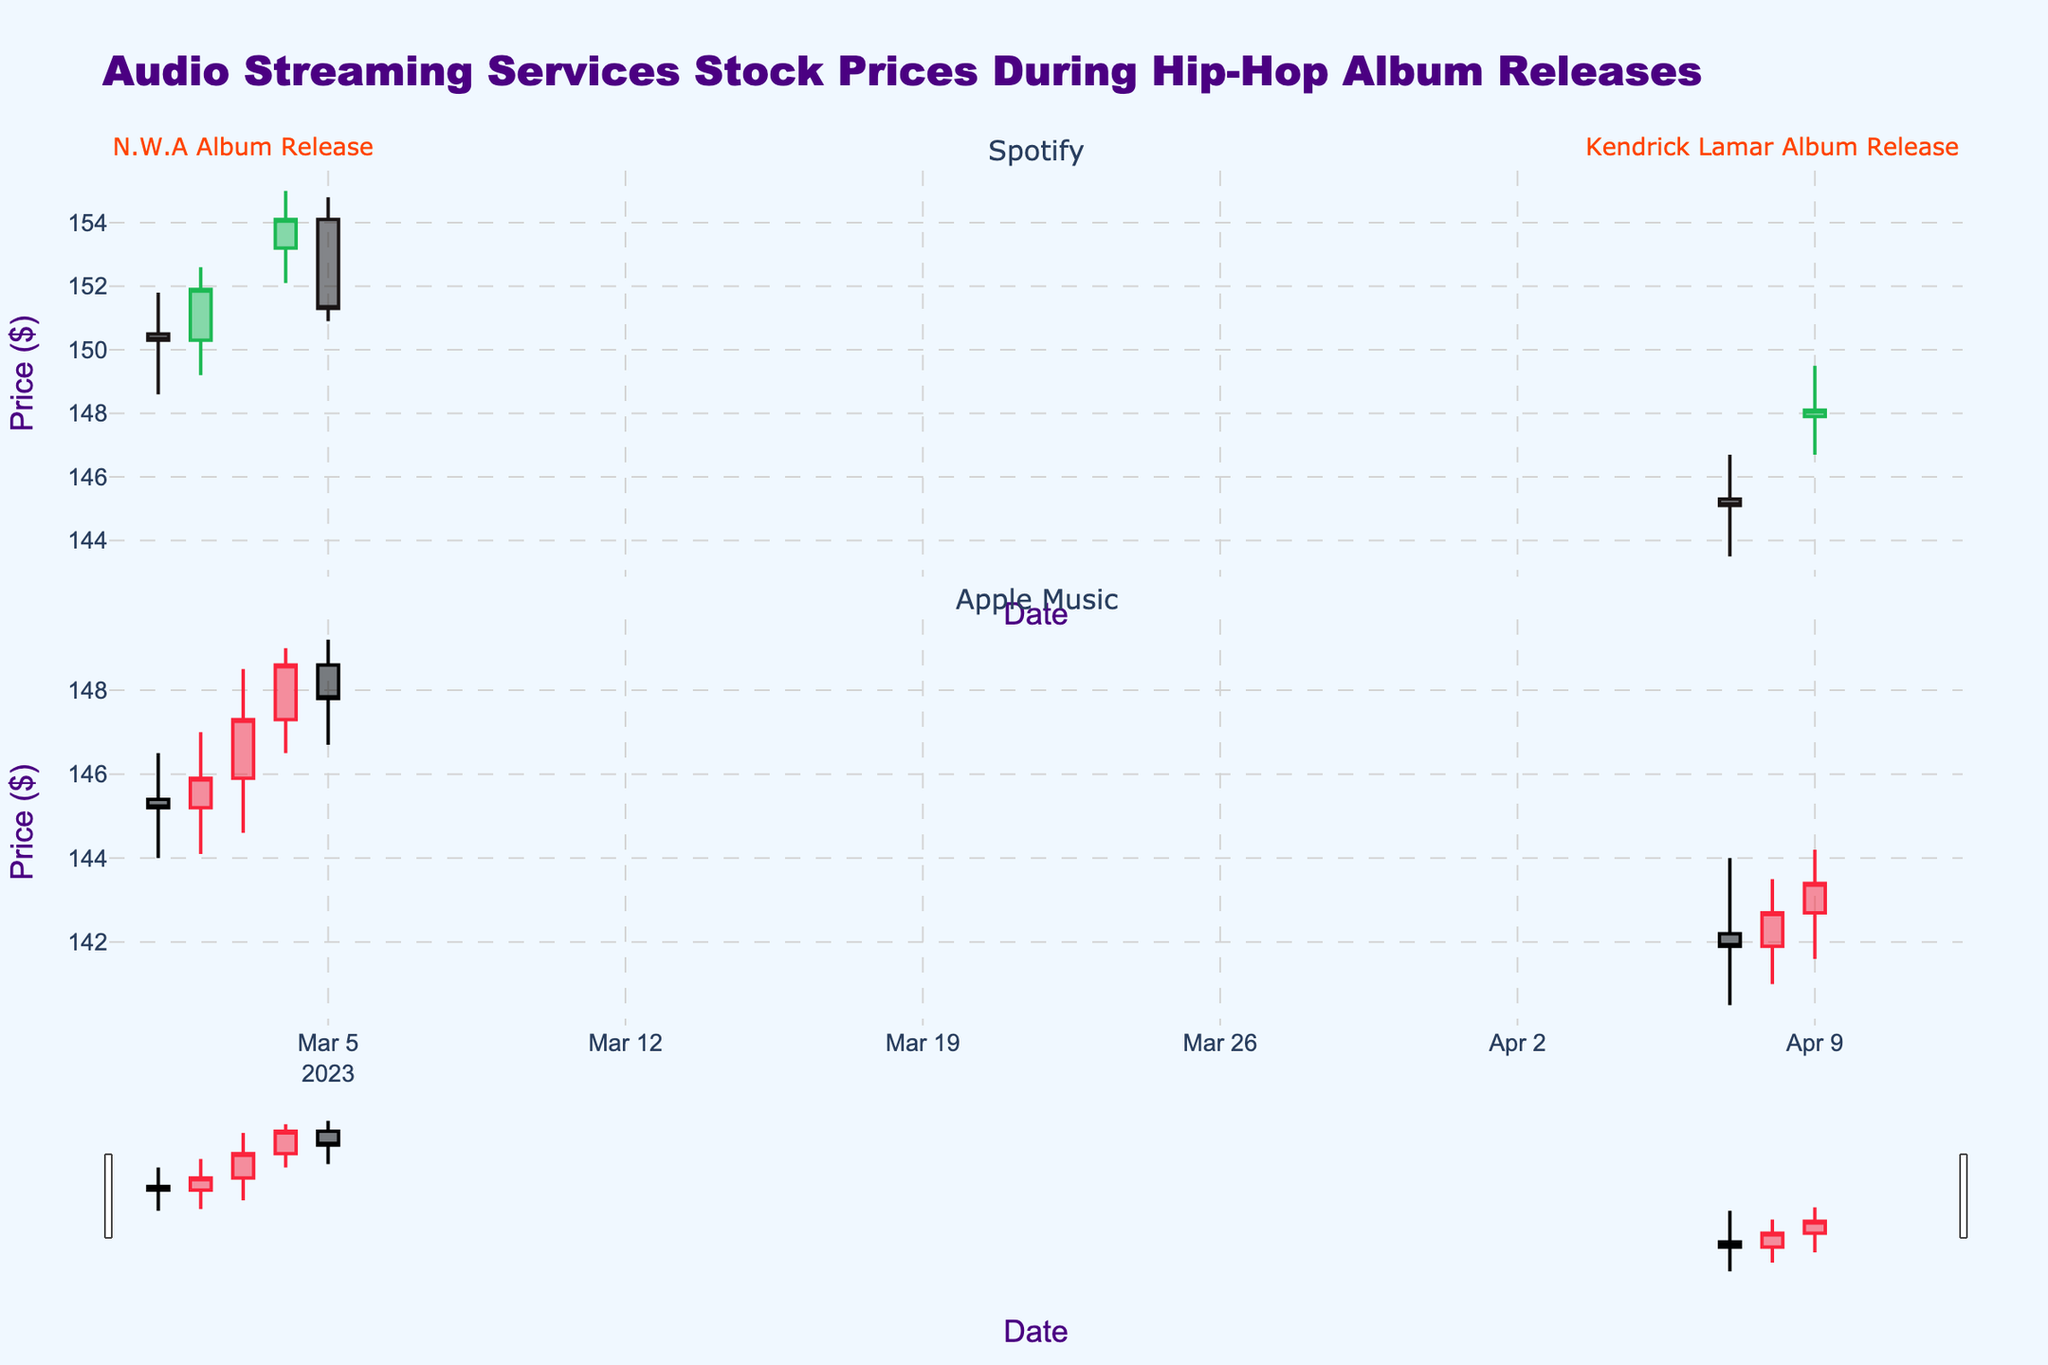What does the title of the plot indicate? The title of the plot, "Audio Streaming Services Stock Prices During Hip-Hop Album Releases," provides an overview that the candlestick chart visualizes the stock price movements of audio streaming services (Spotify and Apple Music) during major hip-hop album releases (N.W.A and Kendrick Lamar).
Answer: It indicates stock price movements during hip-hop album releases What is the highest price point for Spotify on March 3, 2023? On March 3, 2023, Spotify's highest price point can be identified by the top end of the candlestick's wick.
Answer: 153.80 How many data points are plotted for Apple Music? Count the number of distinct candlesticks present under the Apple Music subplot.
Answer: 7 Which company's stock price experienced a decline right after N.W.A's album release on March 3, 2023? Examine the color and direction of the candlesticks after March 3, 2023. For Spotify, there's a green candlestick followed by a red one. For Apple Music, it directly shows a red candlestick after March 3rd.
Answer: Spotify What is the average closing price of Apple Music across the shown dates? Sum the closing prices of Apple Music and divide by the number of data points (7 days). [(145.20 + 145.90 + 147.30 + 148.60 + 147.80 + 141.90 + 142.70 + 143.40) / 7]
Answer: 144.83 Compare the high prices for Spotify and Apple Music on the day of Kendrick Lamar's album release. Which one is higher? Refer to the candlestick high points on April 8, 2023, for both Spotify and Apple Music. Compare the values directly.
Answer: Spotify On what date did Spotify have the highest trading volume, and what was it? The highest volume can be found by looking at the volume data text associated with each date in the subplot.
Answer: March 5, 2023, with 13,000,000 How much did the closing price of Spotify change from March 1 to March 5, 2023? Find the difference between the closing prices on March 1 and March 5: 151.30 - 150.30.
Answer: 1.00 What's the color that represents an increasing line for Spotify stocks? The increasing line color can be identified by observing the green candlesticks or referring to the candlestick properties.
Answer: Green Which company had a greater closing price on April 7, 2023? Directly compare the candlestick close values for both companies on April 7, 2023.
Answer: Spotify 